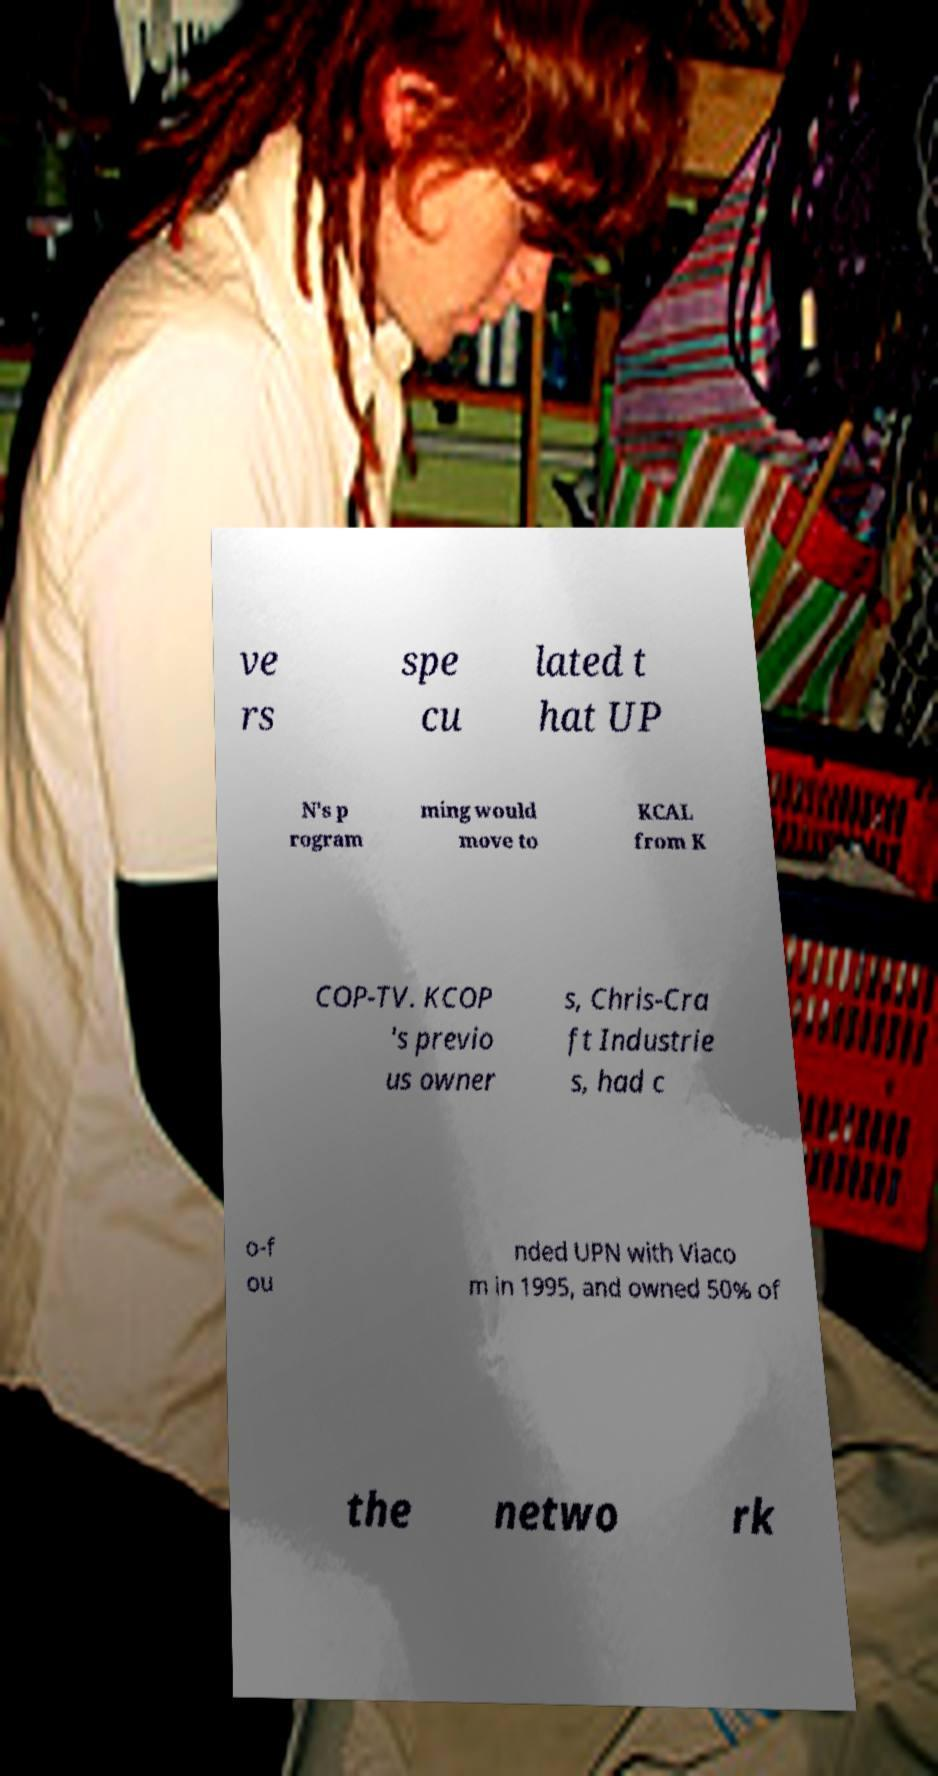For documentation purposes, I need the text within this image transcribed. Could you provide that? ve rs spe cu lated t hat UP N's p rogram ming would move to KCAL from K COP-TV. KCOP 's previo us owner s, Chris-Cra ft Industrie s, had c o-f ou nded UPN with Viaco m in 1995, and owned 50% of the netwo rk 